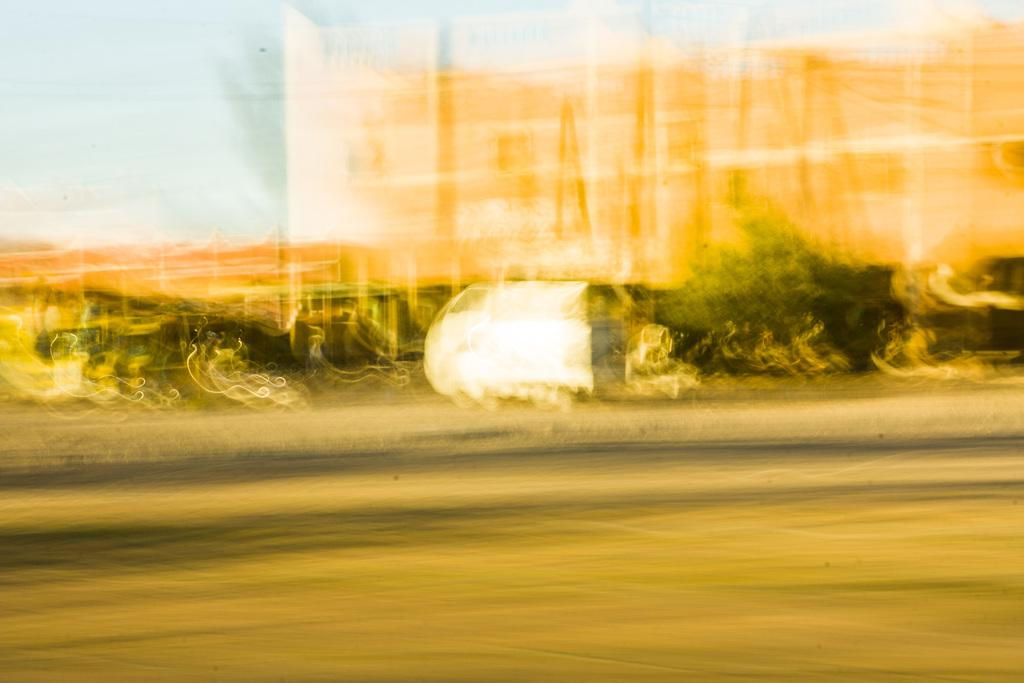What colors are present in the image? The image contains white, green, black, and orange colors. Can you see a pen in the image? There is no pen present in the image. Is there a vest in the image? There is no vest present in the image. 